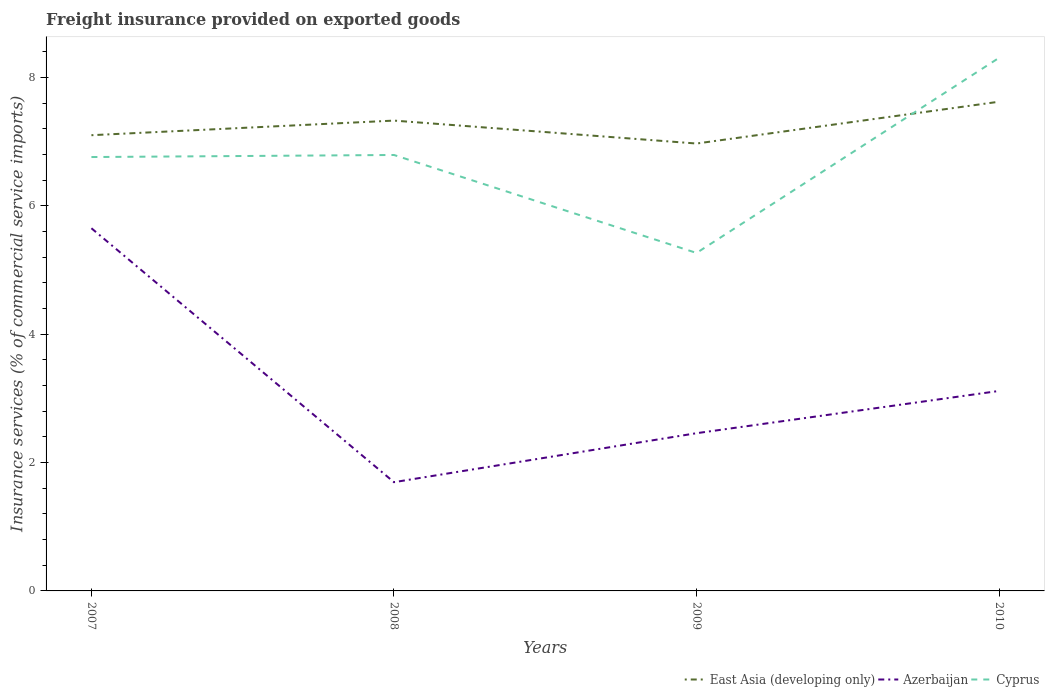Does the line corresponding to East Asia (developing only) intersect with the line corresponding to Cyprus?
Keep it short and to the point. Yes. Is the number of lines equal to the number of legend labels?
Offer a terse response. Yes. Across all years, what is the maximum freight insurance provided on exported goods in East Asia (developing only)?
Provide a succinct answer. 6.97. What is the total freight insurance provided on exported goods in Cyprus in the graph?
Offer a very short reply. -3.04. What is the difference between the highest and the second highest freight insurance provided on exported goods in East Asia (developing only)?
Offer a terse response. 0.65. How many years are there in the graph?
Your answer should be compact. 4. What is the difference between two consecutive major ticks on the Y-axis?
Your response must be concise. 2. Are the values on the major ticks of Y-axis written in scientific E-notation?
Give a very brief answer. No. Where does the legend appear in the graph?
Provide a succinct answer. Bottom right. How many legend labels are there?
Your answer should be compact. 3. How are the legend labels stacked?
Give a very brief answer. Horizontal. What is the title of the graph?
Offer a very short reply. Freight insurance provided on exported goods. Does "Lesotho" appear as one of the legend labels in the graph?
Keep it short and to the point. No. What is the label or title of the Y-axis?
Keep it short and to the point. Insurance services (% of commercial service imports). What is the Insurance services (% of commercial service imports) of East Asia (developing only) in 2007?
Your answer should be very brief. 7.1. What is the Insurance services (% of commercial service imports) in Azerbaijan in 2007?
Make the answer very short. 5.65. What is the Insurance services (% of commercial service imports) in Cyprus in 2007?
Provide a succinct answer. 6.76. What is the Insurance services (% of commercial service imports) of East Asia (developing only) in 2008?
Offer a very short reply. 7.33. What is the Insurance services (% of commercial service imports) in Azerbaijan in 2008?
Your answer should be compact. 1.69. What is the Insurance services (% of commercial service imports) in Cyprus in 2008?
Ensure brevity in your answer.  6.79. What is the Insurance services (% of commercial service imports) of East Asia (developing only) in 2009?
Provide a short and direct response. 6.97. What is the Insurance services (% of commercial service imports) in Azerbaijan in 2009?
Keep it short and to the point. 2.46. What is the Insurance services (% of commercial service imports) of Cyprus in 2009?
Ensure brevity in your answer.  5.27. What is the Insurance services (% of commercial service imports) of East Asia (developing only) in 2010?
Ensure brevity in your answer.  7.62. What is the Insurance services (% of commercial service imports) in Azerbaijan in 2010?
Ensure brevity in your answer.  3.12. What is the Insurance services (% of commercial service imports) in Cyprus in 2010?
Your answer should be very brief. 8.31. Across all years, what is the maximum Insurance services (% of commercial service imports) of East Asia (developing only)?
Offer a terse response. 7.62. Across all years, what is the maximum Insurance services (% of commercial service imports) in Azerbaijan?
Provide a short and direct response. 5.65. Across all years, what is the maximum Insurance services (% of commercial service imports) in Cyprus?
Ensure brevity in your answer.  8.31. Across all years, what is the minimum Insurance services (% of commercial service imports) in East Asia (developing only)?
Your answer should be compact. 6.97. Across all years, what is the minimum Insurance services (% of commercial service imports) in Azerbaijan?
Give a very brief answer. 1.69. Across all years, what is the minimum Insurance services (% of commercial service imports) in Cyprus?
Provide a short and direct response. 5.27. What is the total Insurance services (% of commercial service imports) in East Asia (developing only) in the graph?
Provide a succinct answer. 29.02. What is the total Insurance services (% of commercial service imports) of Azerbaijan in the graph?
Make the answer very short. 12.92. What is the total Insurance services (% of commercial service imports) of Cyprus in the graph?
Give a very brief answer. 27.12. What is the difference between the Insurance services (% of commercial service imports) in East Asia (developing only) in 2007 and that in 2008?
Offer a terse response. -0.23. What is the difference between the Insurance services (% of commercial service imports) of Azerbaijan in 2007 and that in 2008?
Provide a succinct answer. 3.96. What is the difference between the Insurance services (% of commercial service imports) in Cyprus in 2007 and that in 2008?
Ensure brevity in your answer.  -0.03. What is the difference between the Insurance services (% of commercial service imports) of East Asia (developing only) in 2007 and that in 2009?
Keep it short and to the point. 0.13. What is the difference between the Insurance services (% of commercial service imports) in Azerbaijan in 2007 and that in 2009?
Make the answer very short. 3.19. What is the difference between the Insurance services (% of commercial service imports) of Cyprus in 2007 and that in 2009?
Make the answer very short. 1.49. What is the difference between the Insurance services (% of commercial service imports) of East Asia (developing only) in 2007 and that in 2010?
Give a very brief answer. -0.52. What is the difference between the Insurance services (% of commercial service imports) of Azerbaijan in 2007 and that in 2010?
Provide a succinct answer. 2.53. What is the difference between the Insurance services (% of commercial service imports) in Cyprus in 2007 and that in 2010?
Offer a terse response. -1.55. What is the difference between the Insurance services (% of commercial service imports) in East Asia (developing only) in 2008 and that in 2009?
Your answer should be compact. 0.36. What is the difference between the Insurance services (% of commercial service imports) of Azerbaijan in 2008 and that in 2009?
Ensure brevity in your answer.  -0.76. What is the difference between the Insurance services (% of commercial service imports) of Cyprus in 2008 and that in 2009?
Offer a very short reply. 1.53. What is the difference between the Insurance services (% of commercial service imports) of East Asia (developing only) in 2008 and that in 2010?
Make the answer very short. -0.29. What is the difference between the Insurance services (% of commercial service imports) of Azerbaijan in 2008 and that in 2010?
Provide a short and direct response. -1.42. What is the difference between the Insurance services (% of commercial service imports) in Cyprus in 2008 and that in 2010?
Your response must be concise. -1.51. What is the difference between the Insurance services (% of commercial service imports) in East Asia (developing only) in 2009 and that in 2010?
Provide a succinct answer. -0.65. What is the difference between the Insurance services (% of commercial service imports) in Azerbaijan in 2009 and that in 2010?
Your response must be concise. -0.66. What is the difference between the Insurance services (% of commercial service imports) of Cyprus in 2009 and that in 2010?
Your response must be concise. -3.04. What is the difference between the Insurance services (% of commercial service imports) of East Asia (developing only) in 2007 and the Insurance services (% of commercial service imports) of Azerbaijan in 2008?
Ensure brevity in your answer.  5.41. What is the difference between the Insurance services (% of commercial service imports) in East Asia (developing only) in 2007 and the Insurance services (% of commercial service imports) in Cyprus in 2008?
Give a very brief answer. 0.31. What is the difference between the Insurance services (% of commercial service imports) of Azerbaijan in 2007 and the Insurance services (% of commercial service imports) of Cyprus in 2008?
Provide a succinct answer. -1.14. What is the difference between the Insurance services (% of commercial service imports) of East Asia (developing only) in 2007 and the Insurance services (% of commercial service imports) of Azerbaijan in 2009?
Provide a succinct answer. 4.64. What is the difference between the Insurance services (% of commercial service imports) in East Asia (developing only) in 2007 and the Insurance services (% of commercial service imports) in Cyprus in 2009?
Offer a very short reply. 1.83. What is the difference between the Insurance services (% of commercial service imports) of Azerbaijan in 2007 and the Insurance services (% of commercial service imports) of Cyprus in 2009?
Offer a very short reply. 0.38. What is the difference between the Insurance services (% of commercial service imports) of East Asia (developing only) in 2007 and the Insurance services (% of commercial service imports) of Azerbaijan in 2010?
Provide a succinct answer. 3.98. What is the difference between the Insurance services (% of commercial service imports) in East Asia (developing only) in 2007 and the Insurance services (% of commercial service imports) in Cyprus in 2010?
Offer a terse response. -1.21. What is the difference between the Insurance services (% of commercial service imports) of Azerbaijan in 2007 and the Insurance services (% of commercial service imports) of Cyprus in 2010?
Ensure brevity in your answer.  -2.66. What is the difference between the Insurance services (% of commercial service imports) in East Asia (developing only) in 2008 and the Insurance services (% of commercial service imports) in Azerbaijan in 2009?
Your answer should be compact. 4.87. What is the difference between the Insurance services (% of commercial service imports) of East Asia (developing only) in 2008 and the Insurance services (% of commercial service imports) of Cyprus in 2009?
Provide a short and direct response. 2.06. What is the difference between the Insurance services (% of commercial service imports) of Azerbaijan in 2008 and the Insurance services (% of commercial service imports) of Cyprus in 2009?
Make the answer very short. -3.57. What is the difference between the Insurance services (% of commercial service imports) in East Asia (developing only) in 2008 and the Insurance services (% of commercial service imports) in Azerbaijan in 2010?
Provide a succinct answer. 4.21. What is the difference between the Insurance services (% of commercial service imports) of East Asia (developing only) in 2008 and the Insurance services (% of commercial service imports) of Cyprus in 2010?
Your response must be concise. -0.98. What is the difference between the Insurance services (% of commercial service imports) of Azerbaijan in 2008 and the Insurance services (% of commercial service imports) of Cyprus in 2010?
Offer a very short reply. -6.61. What is the difference between the Insurance services (% of commercial service imports) in East Asia (developing only) in 2009 and the Insurance services (% of commercial service imports) in Azerbaijan in 2010?
Offer a terse response. 3.85. What is the difference between the Insurance services (% of commercial service imports) in East Asia (developing only) in 2009 and the Insurance services (% of commercial service imports) in Cyprus in 2010?
Your answer should be very brief. -1.34. What is the difference between the Insurance services (% of commercial service imports) of Azerbaijan in 2009 and the Insurance services (% of commercial service imports) of Cyprus in 2010?
Keep it short and to the point. -5.85. What is the average Insurance services (% of commercial service imports) in East Asia (developing only) per year?
Provide a short and direct response. 7.25. What is the average Insurance services (% of commercial service imports) in Azerbaijan per year?
Provide a short and direct response. 3.23. What is the average Insurance services (% of commercial service imports) in Cyprus per year?
Offer a terse response. 6.78. In the year 2007, what is the difference between the Insurance services (% of commercial service imports) of East Asia (developing only) and Insurance services (% of commercial service imports) of Azerbaijan?
Keep it short and to the point. 1.45. In the year 2007, what is the difference between the Insurance services (% of commercial service imports) in East Asia (developing only) and Insurance services (% of commercial service imports) in Cyprus?
Offer a terse response. 0.34. In the year 2007, what is the difference between the Insurance services (% of commercial service imports) in Azerbaijan and Insurance services (% of commercial service imports) in Cyprus?
Offer a very short reply. -1.11. In the year 2008, what is the difference between the Insurance services (% of commercial service imports) of East Asia (developing only) and Insurance services (% of commercial service imports) of Azerbaijan?
Provide a succinct answer. 5.63. In the year 2008, what is the difference between the Insurance services (% of commercial service imports) of East Asia (developing only) and Insurance services (% of commercial service imports) of Cyprus?
Ensure brevity in your answer.  0.54. In the year 2008, what is the difference between the Insurance services (% of commercial service imports) of Azerbaijan and Insurance services (% of commercial service imports) of Cyprus?
Provide a succinct answer. -5.1. In the year 2009, what is the difference between the Insurance services (% of commercial service imports) in East Asia (developing only) and Insurance services (% of commercial service imports) in Azerbaijan?
Provide a short and direct response. 4.51. In the year 2009, what is the difference between the Insurance services (% of commercial service imports) in East Asia (developing only) and Insurance services (% of commercial service imports) in Cyprus?
Offer a very short reply. 1.7. In the year 2009, what is the difference between the Insurance services (% of commercial service imports) in Azerbaijan and Insurance services (% of commercial service imports) in Cyprus?
Provide a short and direct response. -2.81. In the year 2010, what is the difference between the Insurance services (% of commercial service imports) in East Asia (developing only) and Insurance services (% of commercial service imports) in Azerbaijan?
Ensure brevity in your answer.  4.51. In the year 2010, what is the difference between the Insurance services (% of commercial service imports) of East Asia (developing only) and Insurance services (% of commercial service imports) of Cyprus?
Your answer should be compact. -0.68. In the year 2010, what is the difference between the Insurance services (% of commercial service imports) of Azerbaijan and Insurance services (% of commercial service imports) of Cyprus?
Your answer should be very brief. -5.19. What is the ratio of the Insurance services (% of commercial service imports) in East Asia (developing only) in 2007 to that in 2008?
Offer a very short reply. 0.97. What is the ratio of the Insurance services (% of commercial service imports) in Azerbaijan in 2007 to that in 2008?
Provide a short and direct response. 3.33. What is the ratio of the Insurance services (% of commercial service imports) of Cyprus in 2007 to that in 2008?
Make the answer very short. 1. What is the ratio of the Insurance services (% of commercial service imports) in East Asia (developing only) in 2007 to that in 2009?
Provide a short and direct response. 1.02. What is the ratio of the Insurance services (% of commercial service imports) of Azerbaijan in 2007 to that in 2009?
Ensure brevity in your answer.  2.3. What is the ratio of the Insurance services (% of commercial service imports) of Cyprus in 2007 to that in 2009?
Keep it short and to the point. 1.28. What is the ratio of the Insurance services (% of commercial service imports) in East Asia (developing only) in 2007 to that in 2010?
Offer a very short reply. 0.93. What is the ratio of the Insurance services (% of commercial service imports) of Azerbaijan in 2007 to that in 2010?
Ensure brevity in your answer.  1.81. What is the ratio of the Insurance services (% of commercial service imports) in Cyprus in 2007 to that in 2010?
Your answer should be very brief. 0.81. What is the ratio of the Insurance services (% of commercial service imports) of East Asia (developing only) in 2008 to that in 2009?
Provide a succinct answer. 1.05. What is the ratio of the Insurance services (% of commercial service imports) in Azerbaijan in 2008 to that in 2009?
Ensure brevity in your answer.  0.69. What is the ratio of the Insurance services (% of commercial service imports) in Cyprus in 2008 to that in 2009?
Ensure brevity in your answer.  1.29. What is the ratio of the Insurance services (% of commercial service imports) of East Asia (developing only) in 2008 to that in 2010?
Your answer should be very brief. 0.96. What is the ratio of the Insurance services (% of commercial service imports) of Azerbaijan in 2008 to that in 2010?
Offer a very short reply. 0.54. What is the ratio of the Insurance services (% of commercial service imports) of Cyprus in 2008 to that in 2010?
Your answer should be very brief. 0.82. What is the ratio of the Insurance services (% of commercial service imports) in East Asia (developing only) in 2009 to that in 2010?
Your answer should be compact. 0.91. What is the ratio of the Insurance services (% of commercial service imports) in Azerbaijan in 2009 to that in 2010?
Offer a terse response. 0.79. What is the ratio of the Insurance services (% of commercial service imports) of Cyprus in 2009 to that in 2010?
Offer a very short reply. 0.63. What is the difference between the highest and the second highest Insurance services (% of commercial service imports) in East Asia (developing only)?
Your answer should be very brief. 0.29. What is the difference between the highest and the second highest Insurance services (% of commercial service imports) in Azerbaijan?
Your response must be concise. 2.53. What is the difference between the highest and the second highest Insurance services (% of commercial service imports) in Cyprus?
Your response must be concise. 1.51. What is the difference between the highest and the lowest Insurance services (% of commercial service imports) of East Asia (developing only)?
Make the answer very short. 0.65. What is the difference between the highest and the lowest Insurance services (% of commercial service imports) in Azerbaijan?
Offer a terse response. 3.96. What is the difference between the highest and the lowest Insurance services (% of commercial service imports) in Cyprus?
Give a very brief answer. 3.04. 